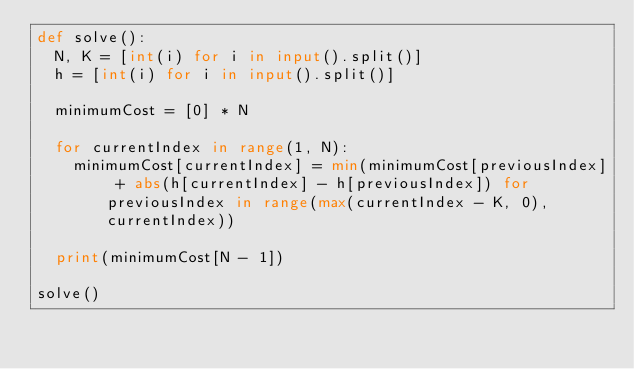<code> <loc_0><loc_0><loc_500><loc_500><_Python_>def solve():
  N, K = [int(i) for i in input().split()]
  h = [int(i) for i in input().split()]

  minimumCost = [0] * N

  for currentIndex in range(1, N):
    minimumCost[currentIndex] = min(minimumCost[previousIndex] + abs(h[currentIndex] - h[previousIndex]) for previousIndex in range(max(currentIndex - K, 0), currentIndex))

  print(minimumCost[N - 1])

solve()
</code> 